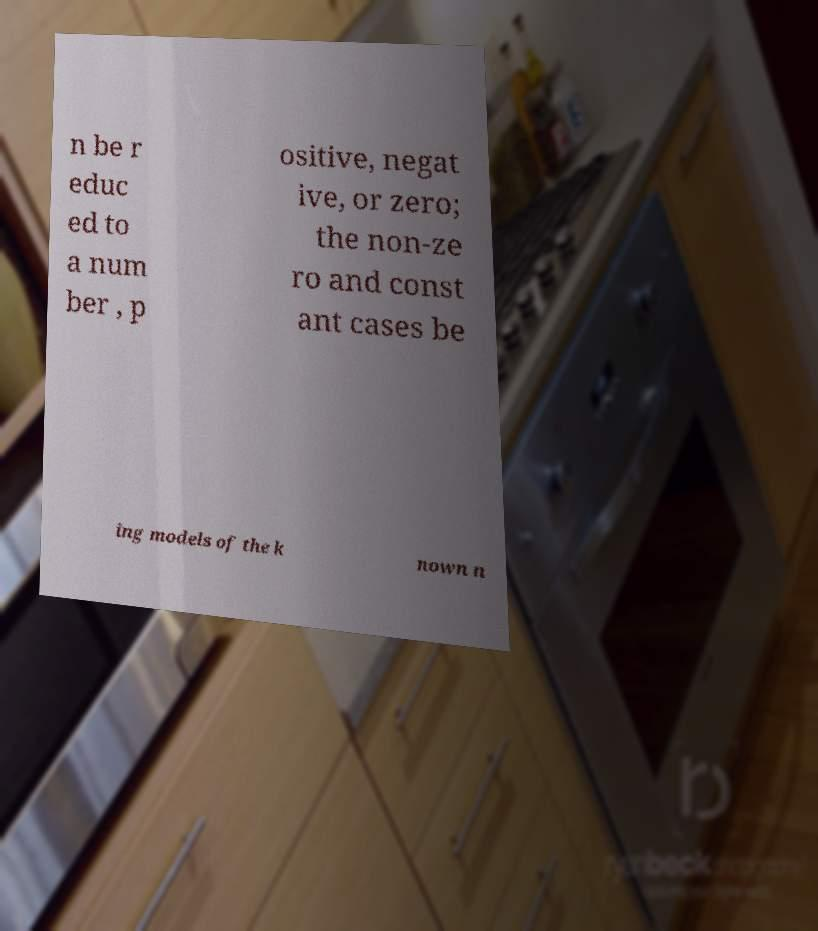I need the written content from this picture converted into text. Can you do that? n be r educ ed to a num ber , p ositive, negat ive, or zero; the non-ze ro and const ant cases be ing models of the k nown n 